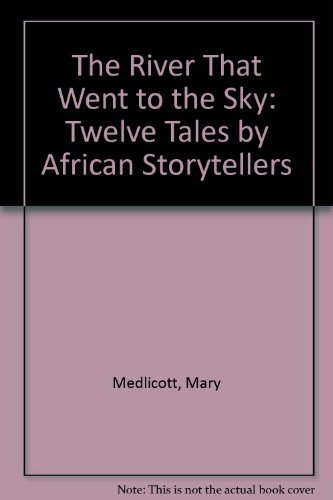Is this a kids book? Yes, it is a children's book designed to captivate and educate young minds with stories rich in African folklore and adventure. 